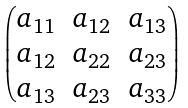<formula> <loc_0><loc_0><loc_500><loc_500>\begin{pmatrix} a _ { 1 1 } & a _ { 1 2 } & a _ { 1 3 } \\ a _ { 1 2 } & a _ { 2 2 } & a _ { 2 3 } \\ a _ { 1 3 } & a _ { 2 3 } & a _ { 3 3 } \end{pmatrix}</formula> 